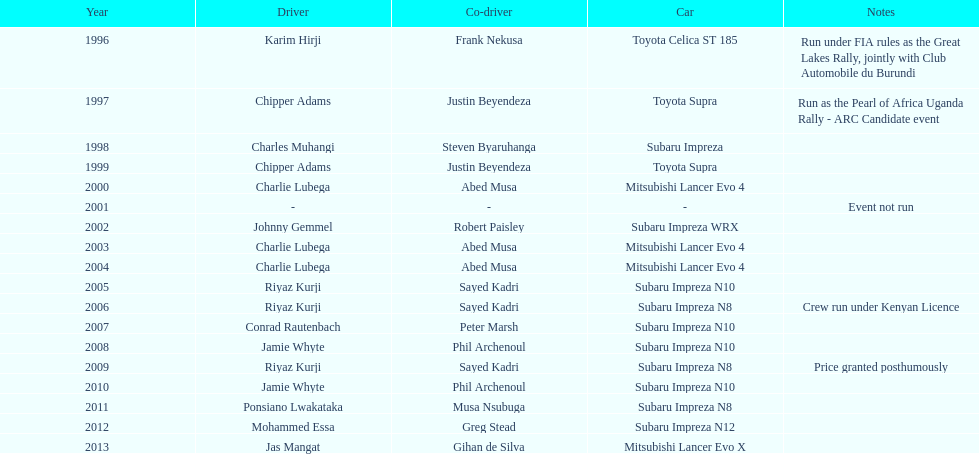How frequently did charlie lubega take on the role of a driver? 3. 